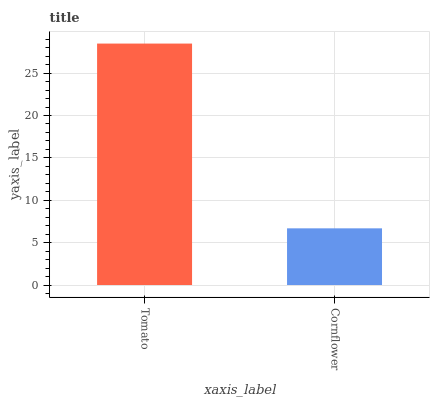Is Cornflower the minimum?
Answer yes or no. Yes. Is Tomato the maximum?
Answer yes or no. Yes. Is Cornflower the maximum?
Answer yes or no. No. Is Tomato greater than Cornflower?
Answer yes or no. Yes. Is Cornflower less than Tomato?
Answer yes or no. Yes. Is Cornflower greater than Tomato?
Answer yes or no. No. Is Tomato less than Cornflower?
Answer yes or no. No. Is Tomato the high median?
Answer yes or no. Yes. Is Cornflower the low median?
Answer yes or no. Yes. Is Cornflower the high median?
Answer yes or no. No. Is Tomato the low median?
Answer yes or no. No. 